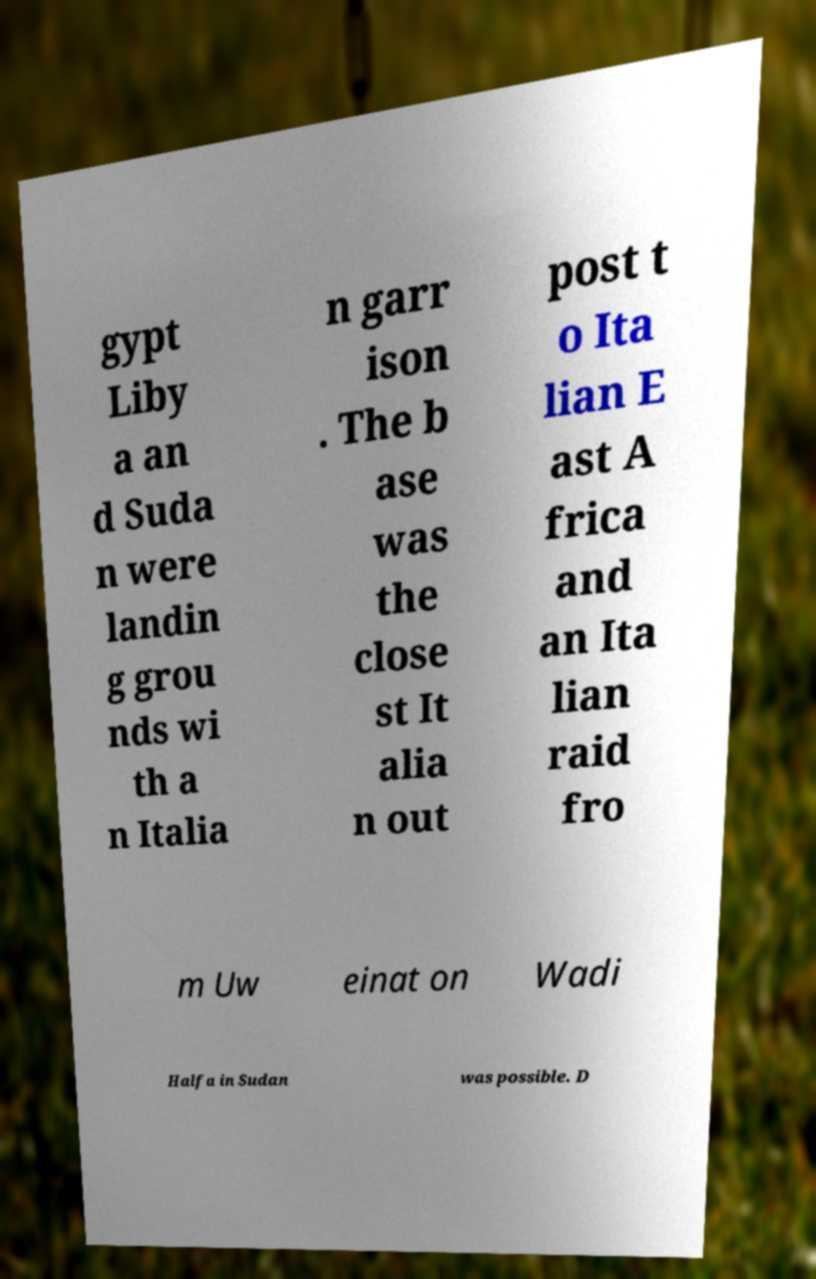There's text embedded in this image that I need extracted. Can you transcribe it verbatim? gypt Liby a an d Suda n were landin g grou nds wi th a n Italia n garr ison . The b ase was the close st It alia n out post t o Ita lian E ast A frica and an Ita lian raid fro m Uw einat on Wadi Halfa in Sudan was possible. D 